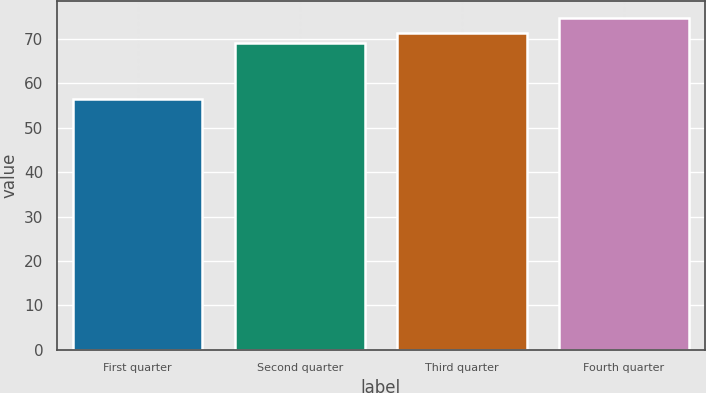<chart> <loc_0><loc_0><loc_500><loc_500><bar_chart><fcel>First quarter<fcel>Second quarter<fcel>Third quarter<fcel>Fourth quarter<nl><fcel>56.61<fcel>69.09<fcel>71.35<fcel>74.81<nl></chart> 